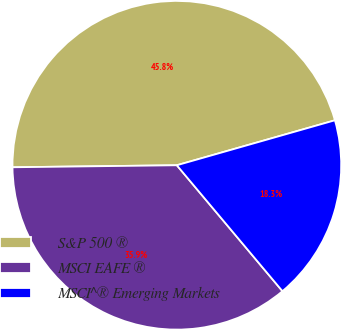Convert chart to OTSL. <chart><loc_0><loc_0><loc_500><loc_500><pie_chart><fcel>S&P 500 ®<fcel>MSCI EAFE ®<fcel>MSCI^® Emerging Markets<nl><fcel>45.78%<fcel>35.91%<fcel>18.3%<nl></chart> 